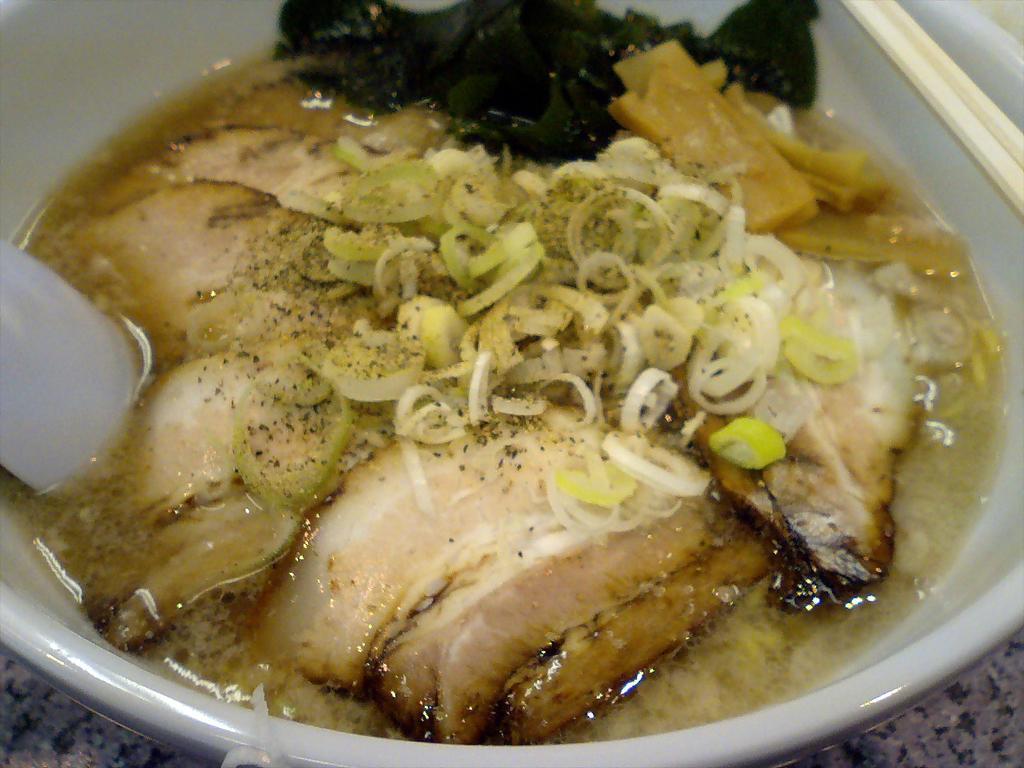How would you summarize this image in a sentence or two? In this image I can see food in the bowl. 